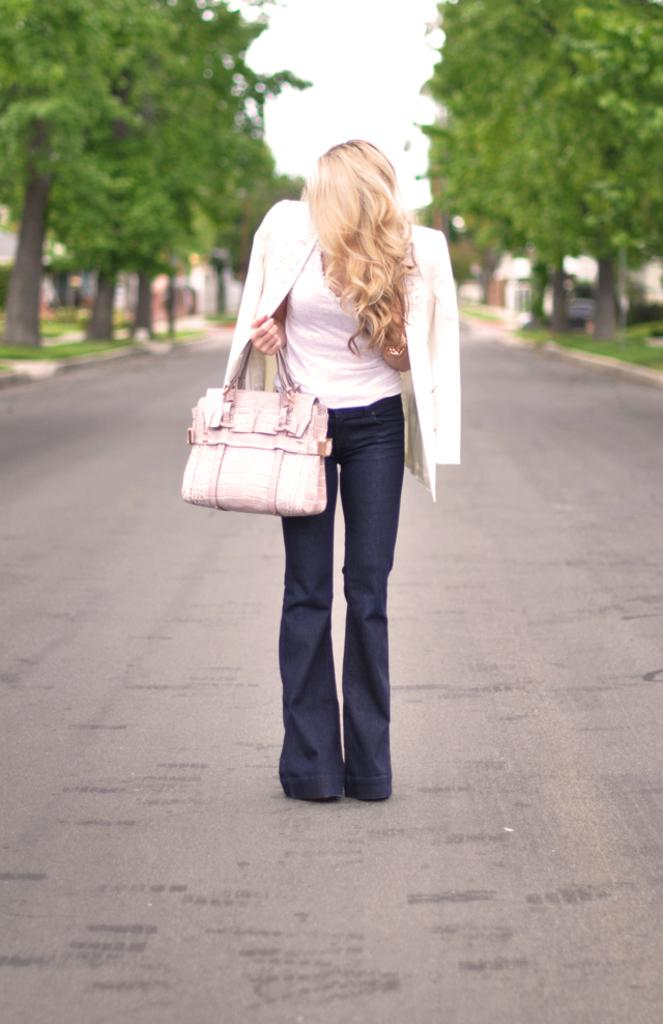What is the main feature of the image? There is a road in the image. Who or what is on the road? A woman is standing on the road. What is the woman wearing? The woman is wearing a jacket. What is the woman holding in her hand? The woman is carrying a bag in her hand. What can be seen in the distance in the image? There are trees visible in the background of the image. What type of book is the woman reading while standing on the road? There is no book present in the image, and the woman is not reading. 